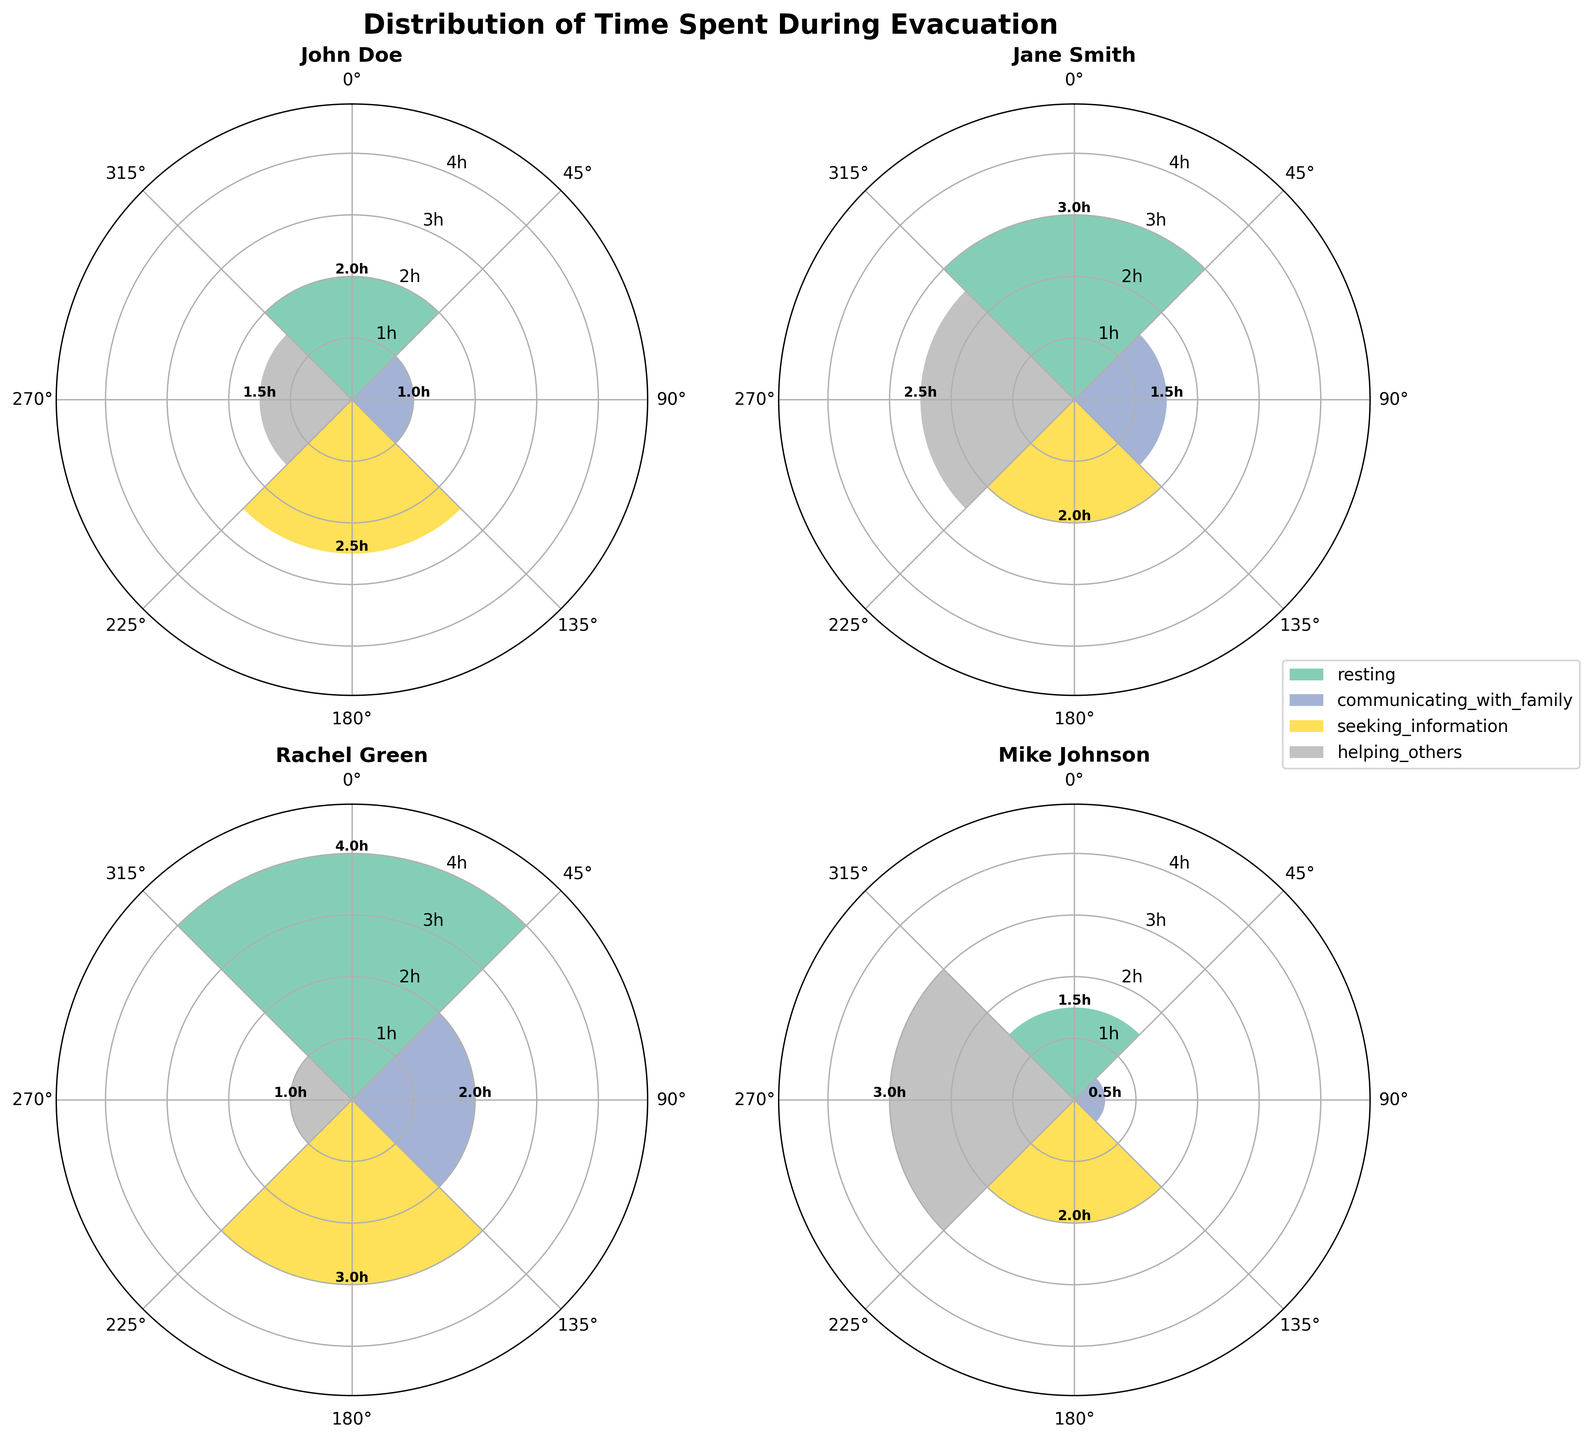what is the title of the figure? The title of the figure is displayed prominently at the top of the chart, which is usually easy to locate.
Answer: Distribution of Time Spent During Evacuation Who spent the most time resting? By examining the bar representing "resting" for each person, the tallest bar indicates the most time spent. The highest bar in the resting category is Rachel Green's.
Answer: Rachel Green What is the average time spent communicating with family? We need to add up the time spent communicating with family for all individuals and then divide by the number of individuals: (1 + 1.5 + 2 + 0.5) / 4 = 5 / 4 = 1.25 hours.
Answer: 1.25 hours Who spent more time helping others, Mike Johnson or John Doe? By comparing the bars representing "helping others" for Mike Johnson and John Doe, we see that Mike's bar is taller. Specifically, Mike Johnson spent 3 hours, and John Doe spent 1.5 hours helping others.
Answer: Mike Johnson Which activity did Jane Smith spend the most time on? By looking at Jane Smith's sub-plot and comparing the heights of the bars for each activity, the tallest bar corresponds to "helping others," which is 2.5 hours.
Answer: Helping others What is the combined time that Rachel Green spent resting and seeking information? Sum Rachel Green's time spent resting and seeking information: 4 + 3 = 7 hours.
Answer: 7 hours How does the time spent seeking information by John Doe compare to that of Jane Smith? Comparing the heights of the bars for seeking information in John Doe’s and Jane Smith’s sub-plots, John Doe's 2.5 hours bar is taller than Jane Smith's 2 hours bar.
Answer: John Doe spent more time What is the total time Mike Johnson spent on all activities during the evacuation? Sum up the hours Mike Johnson spent on each activity: 1.5 (resting) + 0.5 (communicating with family) + 2 (seeking information) + 3 (helping others) = 7 hours.
Answer: 7 hours What is the activity with the shortest average time spent across all individuals? Calculating the average time for each activity: 
- Resting: (2+3+4+1.5)/4 = 2.625 hours 
- Communicating with family: (1+1.5+2+0.5)/4 = 1.25 hours 
- Seeking information: (2.5+2+3+2)/4 = 2.375 hours 
- Helping others: (1.5+2.5+1+3)/4 = 2 hours
Answer: Communicating with family Do any of the individuals spend equal time on more than one activity? Checking the bars of each individual to see if any have bars of the same height: 
John Doe: No
Jane Smith: No
Rachel Green: No
Mike Johnson: No
Answer: No 